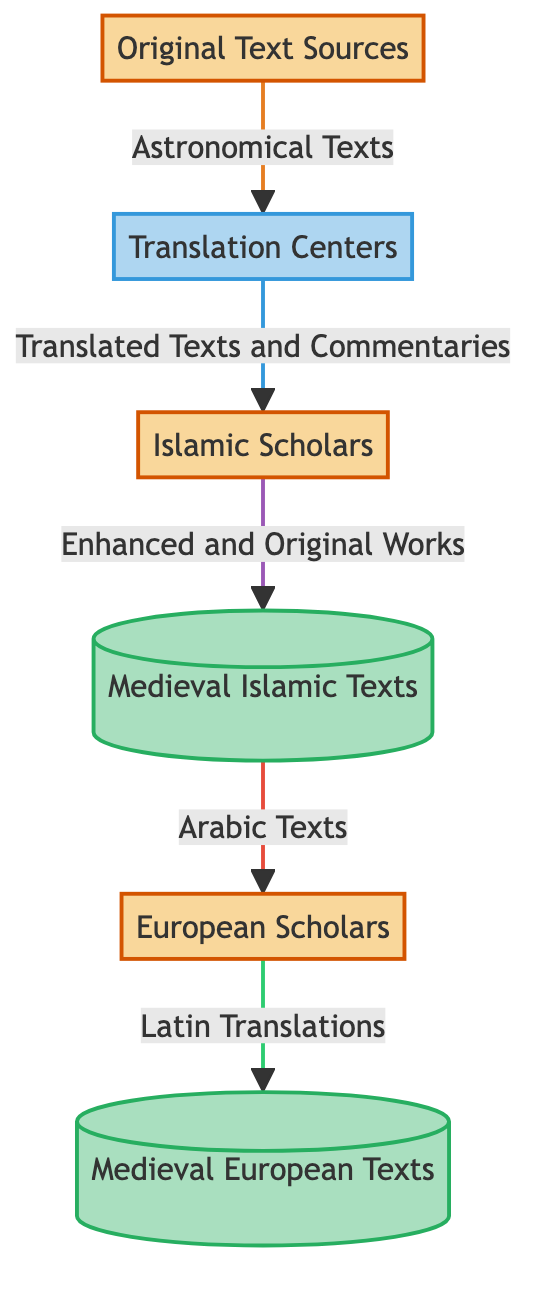What are the original text sources? The diagram identifies "Original Text Sources" as ancient Greek and Indian astronomical works, specifically mentioning Ptolemy's Almagest and Aryabhatiya.
Answer: Ancient Greek and Indian astronomical works Who are the Islamic scholars? The diagram defines "Islamic Scholars" as thinkers like Al-Battani, Al-Sufi, and Ibn al-Haytham who contribute to the field by translating and commenting on original texts.
Answer: Al-Battani, Al-Sufi, Ibn al-Haytham What type of entity is the Translation Centers? The diagram classifies "Translation Centers" as a "Process," indicating it is an activity rather than a static entity.
Answer: Process How many data flows are there in the diagram? To determine this, we can count the arrows that represent data flows between entities. The diagram shows five distinct flows.
Answer: Five What do Islamic scholars produce? The diagram specifies that the output from Islamic Scholars is "Enhanced and Original Works," indicating their contributions to astronomy.
Answer: Enhanced and Original Works Which texts are transmitted to European scholars? Looking at the diagram, it indicates that the "Medieval Islamic Texts" are transmitted to European scholars as "Arabic Texts."
Answer: Arabic Texts How do European scholars create their texts? According to the diagram, European Scholars create texts through the process of making "Latin Translations" from the Arabic works they received.
Answer: Latin Translations What is the relationship between Translation Centers and Medieval Islamic Texts? The diagram shows that Translation Centers provide "Translated Texts and Commentaries" to Islamic Scholars, who then produce Medieval Islamic Texts.
Answer: Translated Texts and Commentaries What does the data flow from Medieval Islamic Texts represent? The data flow from Medieval Islamic Texts to European Scholars represents "Arabic Texts," indicating the transmission of knowledge between cultures.
Answer: Arabic Texts 